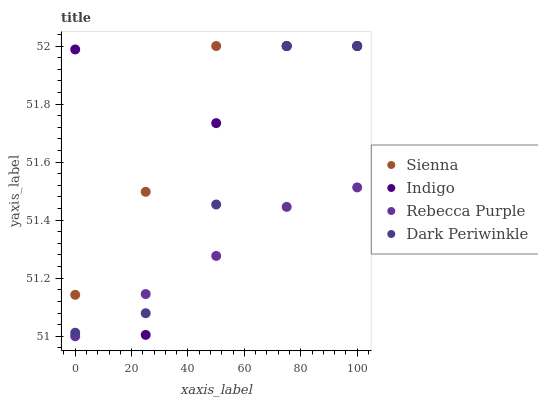Does Rebecca Purple have the minimum area under the curve?
Answer yes or no. Yes. Does Sienna have the maximum area under the curve?
Answer yes or no. Yes. Does Indigo have the minimum area under the curve?
Answer yes or no. No. Does Indigo have the maximum area under the curve?
Answer yes or no. No. Is Rebecca Purple the smoothest?
Answer yes or no. Yes. Is Indigo the roughest?
Answer yes or no. Yes. Is Indigo the smoothest?
Answer yes or no. No. Is Rebecca Purple the roughest?
Answer yes or no. No. Does Rebecca Purple have the lowest value?
Answer yes or no. Yes. Does Indigo have the lowest value?
Answer yes or no. No. Does Dark Periwinkle have the highest value?
Answer yes or no. Yes. Does Rebecca Purple have the highest value?
Answer yes or no. No. Is Rebecca Purple less than Sienna?
Answer yes or no. Yes. Is Sienna greater than Rebecca Purple?
Answer yes or no. Yes. Does Sienna intersect Dark Periwinkle?
Answer yes or no. Yes. Is Sienna less than Dark Periwinkle?
Answer yes or no. No. Is Sienna greater than Dark Periwinkle?
Answer yes or no. No. Does Rebecca Purple intersect Sienna?
Answer yes or no. No. 